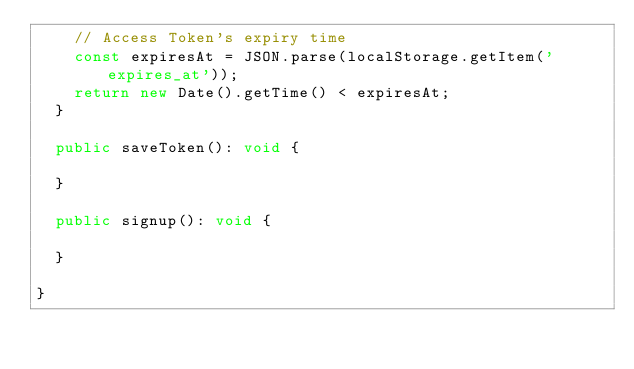Convert code to text. <code><loc_0><loc_0><loc_500><loc_500><_TypeScript_>    // Access Token's expiry time
    const expiresAt = JSON.parse(localStorage.getItem('expires_at'));
    return new Date().getTime() < expiresAt;
  }

  public saveToken(): void {

  }

  public signup(): void {

  }

}</code> 